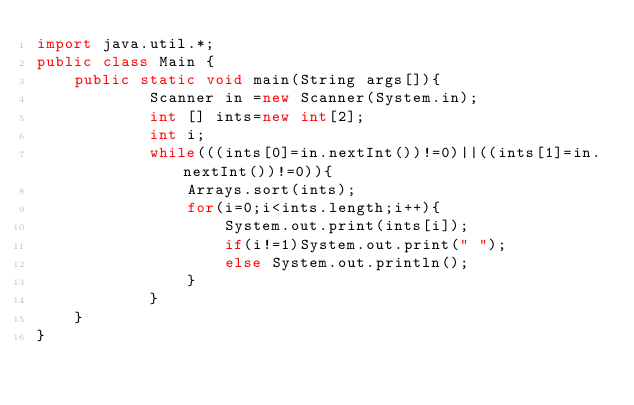<code> <loc_0><loc_0><loc_500><loc_500><_Java_>import java.util.*;
public class Main {
    public static void main(String args[]){
            Scanner in =new Scanner(System.in);
            int [] ints=new int[2];
            int i;
            while(((ints[0]=in.nextInt())!=0)||((ints[1]=in.nextInt())!=0)){
                Arrays.sort(ints);
                for(i=0;i<ints.length;i++){
                    System.out.print(ints[i]);
                    if(i!=1)System.out.print(" ");
                    else System.out.println();
                }
            }   
    }
}</code> 